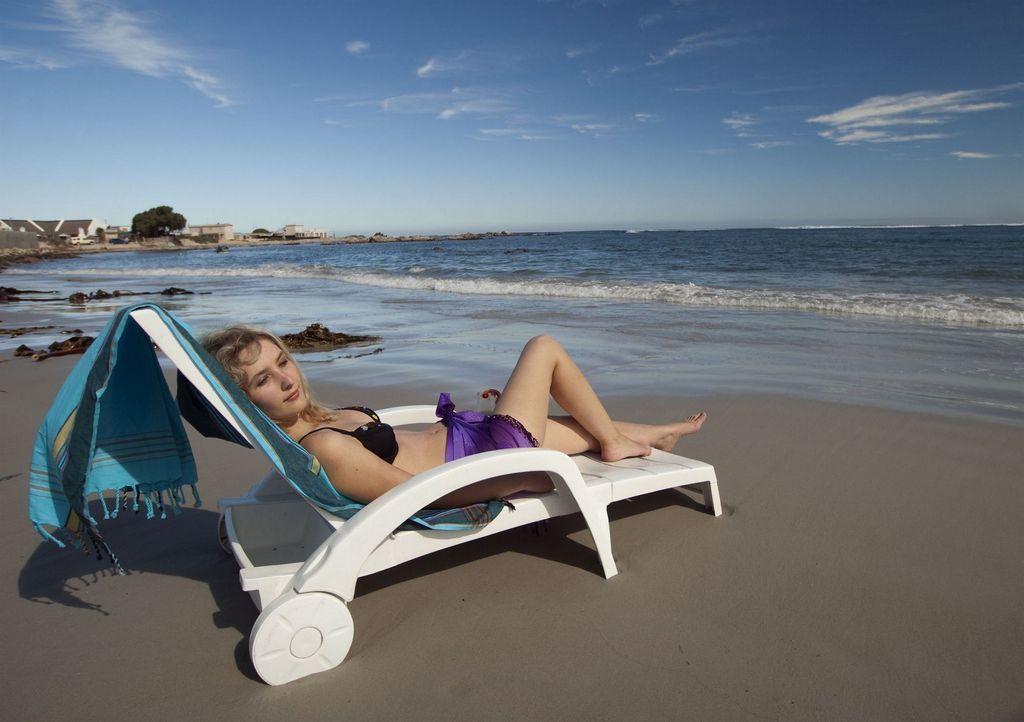Could you give a brief overview of what you see in this image? In this image I can see the sand and the bench which is white in color. On the bench I can see a blue colored cloth and a woman wearing black and violet color dress is lying. In the background I can see the water, few buildings, a tree and the sky. 